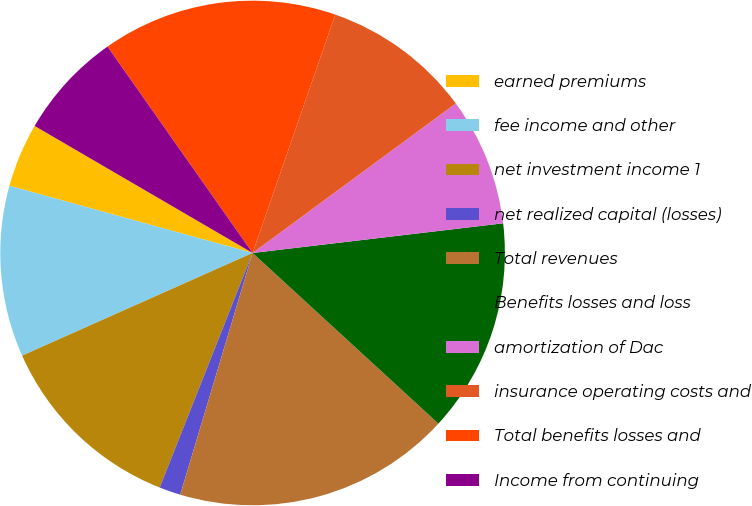Convert chart to OTSL. <chart><loc_0><loc_0><loc_500><loc_500><pie_chart><fcel>earned premiums<fcel>fee income and other<fcel>net investment income 1<fcel>net realized capital (losses)<fcel>Total revenues<fcel>Benefits losses and loss<fcel>amortization of Dac<fcel>insurance operating costs and<fcel>Total benefits losses and<fcel>Income from continuing<nl><fcel>4.11%<fcel>10.96%<fcel>12.33%<fcel>1.37%<fcel>17.81%<fcel>13.7%<fcel>8.22%<fcel>9.59%<fcel>15.07%<fcel>6.85%<nl></chart> 